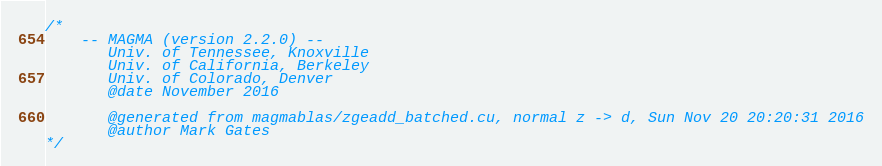<code> <loc_0><loc_0><loc_500><loc_500><_Cuda_>/*
    -- MAGMA (version 2.2.0) --
       Univ. of Tennessee, Knoxville
       Univ. of California, Berkeley
       Univ. of Colorado, Denver
       @date November 2016

       @generated from magmablas/zgeadd_batched.cu, normal z -> d, Sun Nov 20 20:20:31 2016
       @author Mark Gates
*/</code> 